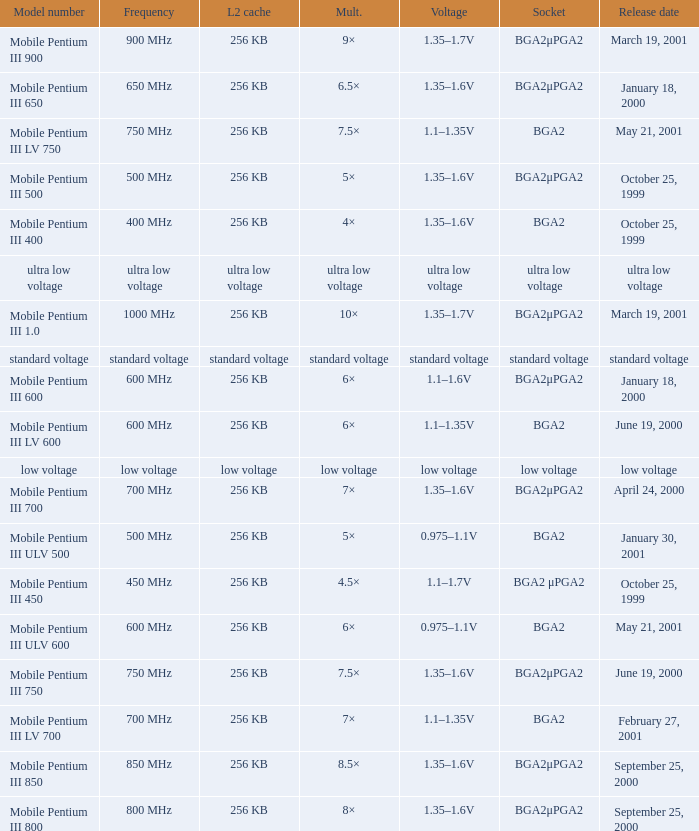What model number uses standard voltage socket? Standard voltage. 